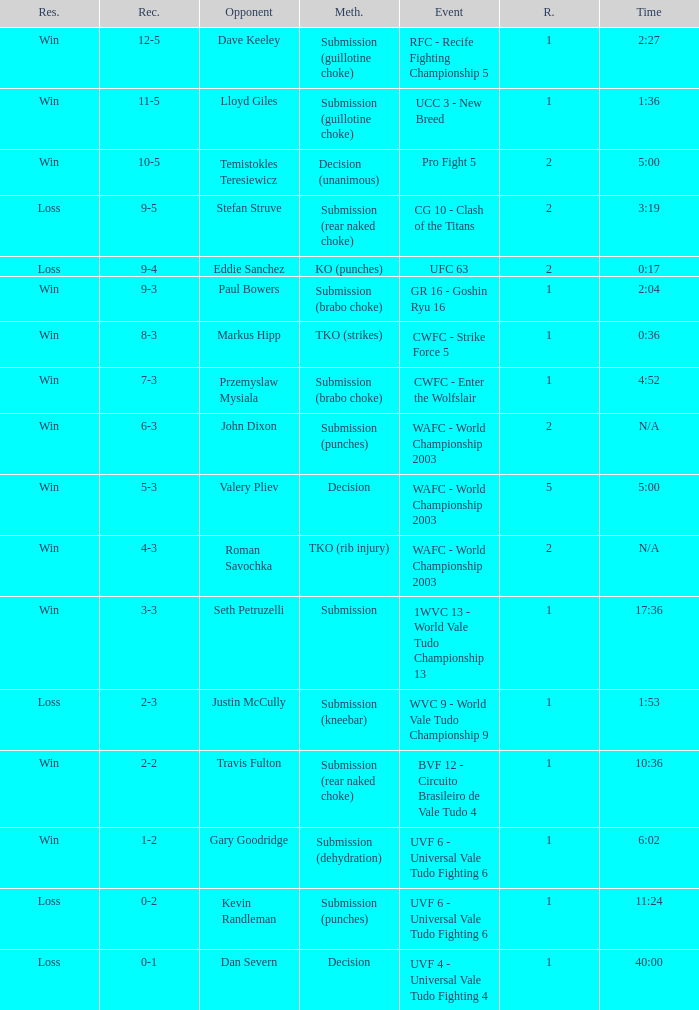What opponent uses the method of decision and a 5-3 record? Valery Pliev. 